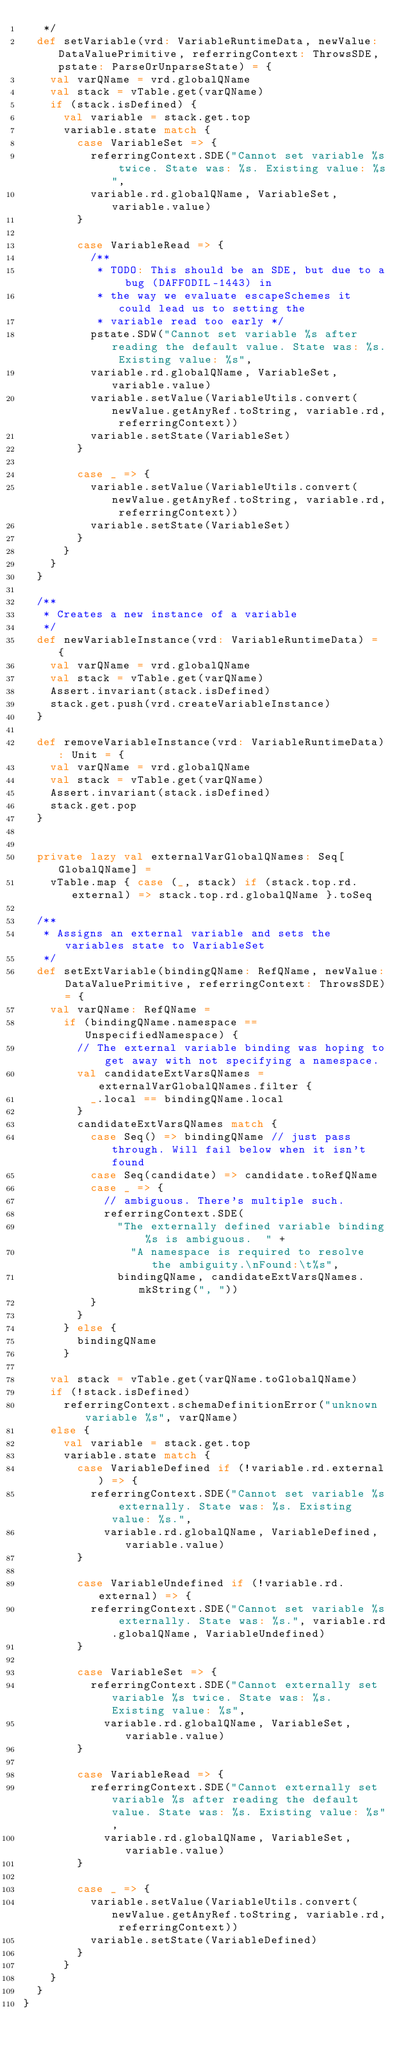Convert code to text. <code><loc_0><loc_0><loc_500><loc_500><_Scala_>   */
  def setVariable(vrd: VariableRuntimeData, newValue: DataValuePrimitive, referringContext: ThrowsSDE, pstate: ParseOrUnparseState) = {
    val varQName = vrd.globalQName
    val stack = vTable.get(varQName)
    if (stack.isDefined) {
      val variable = stack.get.top
      variable.state match {
        case VariableSet => {
          referringContext.SDE("Cannot set variable %s twice. State was: %s. Existing value: %s",
          variable.rd.globalQName, VariableSet, variable.value)
        }

        case VariableRead => {
          /**
           * TODO: This should be an SDE, but due to a bug (DAFFODIL-1443) in
           * the way we evaluate escapeSchemes it could lead us to setting the
           * variable read too early */
          pstate.SDW("Cannot set variable %s after reading the default value. State was: %s. Existing value: %s",
          variable.rd.globalQName, VariableSet, variable.value)
          variable.setValue(VariableUtils.convert(newValue.getAnyRef.toString, variable.rd, referringContext))
          variable.setState(VariableSet)
        }

        case _ => {
          variable.setValue(VariableUtils.convert(newValue.getAnyRef.toString, variable.rd, referringContext))
          variable.setState(VariableSet)
        }
      }
    }
  }

  /**
   * Creates a new instance of a variable
   */
  def newVariableInstance(vrd: VariableRuntimeData) = {
    val varQName = vrd.globalQName
    val stack = vTable.get(varQName)
    Assert.invariant(stack.isDefined)
    stack.get.push(vrd.createVariableInstance)
  }

  def removeVariableInstance(vrd: VariableRuntimeData): Unit = {
    val varQName = vrd.globalQName
    val stack = vTable.get(varQName)
    Assert.invariant(stack.isDefined)
    stack.get.pop
  }


  private lazy val externalVarGlobalQNames: Seq[GlobalQName] =
    vTable.map { case (_, stack) if (stack.top.rd.external) => stack.top.rd.globalQName }.toSeq

  /**
   * Assigns an external variable and sets the variables state to VariableSet
   */
  def setExtVariable(bindingQName: RefQName, newValue: DataValuePrimitive, referringContext: ThrowsSDE) = {
    val varQName: RefQName =
      if (bindingQName.namespace == UnspecifiedNamespace) {
        // The external variable binding was hoping to get away with not specifying a namespace.
        val candidateExtVarsQNames = externalVarGlobalQNames.filter {
          _.local == bindingQName.local
        }
        candidateExtVarsQNames match {
          case Seq() => bindingQName // just pass through. Will fail below when it isn't found
          case Seq(candidate) => candidate.toRefQName
          case _ => {
            // ambiguous. There's multiple such.
            referringContext.SDE(
              "The externally defined variable binding %s is ambiguous.  " +
                "A namespace is required to resolve the ambiguity.\nFound:\t%s",
              bindingQName, candidateExtVarsQNames.mkString(", "))
          }
        }
      } else {
        bindingQName
      }

    val stack = vTable.get(varQName.toGlobalQName)
    if (!stack.isDefined)
      referringContext.schemaDefinitionError("unknown variable %s", varQName)
    else {
      val variable = stack.get.top
      variable.state match {
        case VariableDefined if (!variable.rd.external) => {
          referringContext.SDE("Cannot set variable %s externally. State was: %s. Existing value: %s.",
            variable.rd.globalQName, VariableDefined, variable.value)
        }

        case VariableUndefined if (!variable.rd.external) => {
          referringContext.SDE("Cannot set variable %s externally. State was: %s.", variable.rd.globalQName, VariableUndefined)
        }

        case VariableSet => {
          referringContext.SDE("Cannot externally set variable %s twice. State was: %s. Existing value: %s",
            variable.rd.globalQName, VariableSet, variable.value)
        }

        case VariableRead => {
          referringContext.SDE("Cannot externally set variable %s after reading the default value. State was: %s. Existing value: %s",
            variable.rd.globalQName, VariableSet, variable.value)
        }

        case _ => {
          variable.setValue(VariableUtils.convert(newValue.getAnyRef.toString, variable.rd, referringContext))
          variable.setState(VariableDefined)
        }
      }
    }
  }
}
</code> 